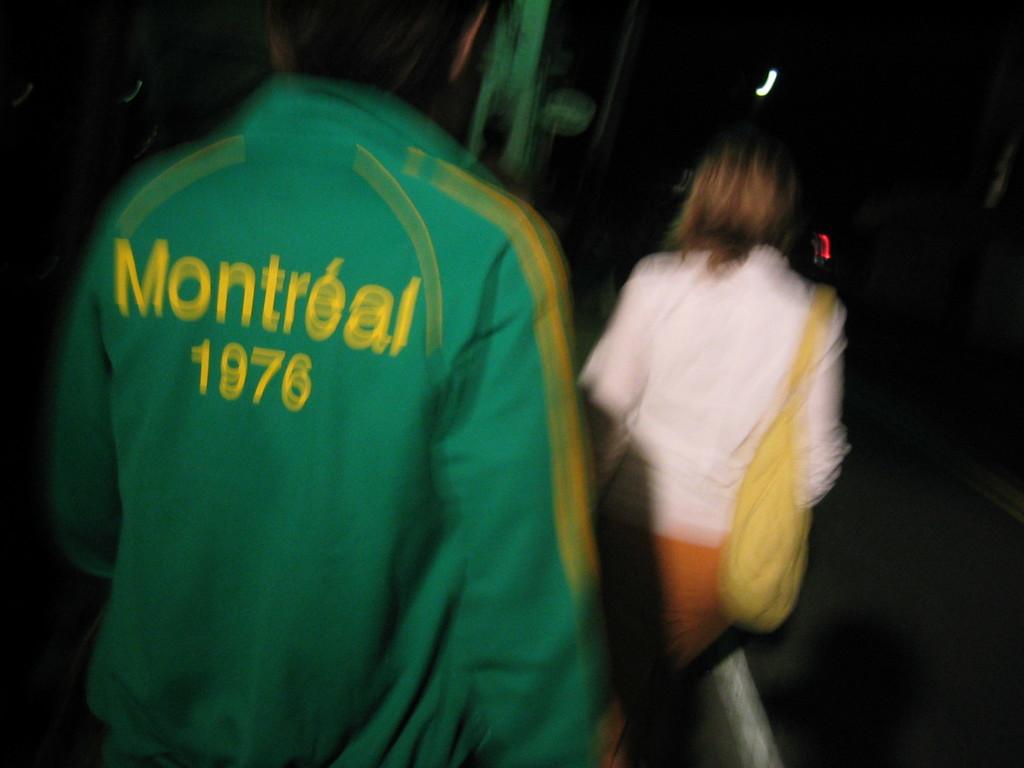What canadian city is embroidered on the man's green jacket?
Provide a succinct answer. Montreal. What year is the jacket displaying?
Provide a succinct answer. 1976. 